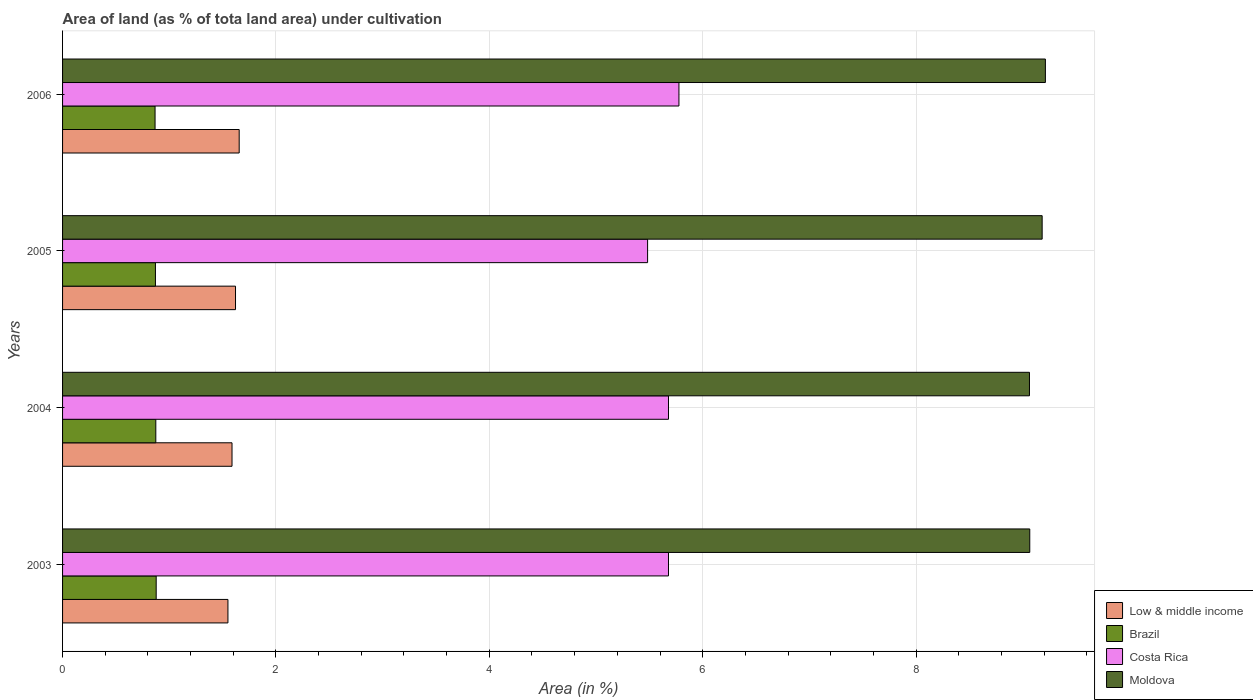How many groups of bars are there?
Offer a very short reply. 4. Are the number of bars on each tick of the Y-axis equal?
Provide a short and direct response. Yes. How many bars are there on the 2nd tick from the bottom?
Make the answer very short. 4. What is the percentage of land under cultivation in Costa Rica in 2005?
Keep it short and to the point. 5.48. Across all years, what is the maximum percentage of land under cultivation in Costa Rica?
Your answer should be very brief. 5.78. Across all years, what is the minimum percentage of land under cultivation in Brazil?
Provide a short and direct response. 0.87. In which year was the percentage of land under cultivation in Brazil minimum?
Your answer should be compact. 2006. What is the total percentage of land under cultivation in Moldova in the graph?
Ensure brevity in your answer.  36.52. What is the difference between the percentage of land under cultivation in Low & middle income in 2004 and that in 2006?
Your response must be concise. -0.07. What is the difference between the percentage of land under cultivation in Costa Rica in 2004 and the percentage of land under cultivation in Low & middle income in 2005?
Ensure brevity in your answer.  4.06. What is the average percentage of land under cultivation in Brazil per year?
Your answer should be very brief. 0.87. In the year 2004, what is the difference between the percentage of land under cultivation in Moldova and percentage of land under cultivation in Costa Rica?
Offer a very short reply. 3.38. What is the ratio of the percentage of land under cultivation in Costa Rica in 2004 to that in 2005?
Your response must be concise. 1.04. Is the difference between the percentage of land under cultivation in Moldova in 2003 and 2004 greater than the difference between the percentage of land under cultivation in Costa Rica in 2003 and 2004?
Offer a very short reply. Yes. What is the difference between the highest and the second highest percentage of land under cultivation in Low & middle income?
Your answer should be compact. 0.03. What is the difference between the highest and the lowest percentage of land under cultivation in Low & middle income?
Provide a short and direct response. 0.11. What does the 4th bar from the top in 2004 represents?
Make the answer very short. Low & middle income. How many bars are there?
Your answer should be very brief. 16. Are all the bars in the graph horizontal?
Your response must be concise. Yes. What is the difference between two consecutive major ticks on the X-axis?
Offer a terse response. 2. Where does the legend appear in the graph?
Your answer should be compact. Bottom right. How many legend labels are there?
Provide a succinct answer. 4. What is the title of the graph?
Offer a terse response. Area of land (as % of tota land area) under cultivation. What is the label or title of the X-axis?
Provide a short and direct response. Area (in %). What is the label or title of the Y-axis?
Provide a short and direct response. Years. What is the Area (in %) of Low & middle income in 2003?
Keep it short and to the point. 1.55. What is the Area (in %) in Brazil in 2003?
Keep it short and to the point. 0.88. What is the Area (in %) in Costa Rica in 2003?
Your response must be concise. 5.68. What is the Area (in %) of Moldova in 2003?
Ensure brevity in your answer.  9.07. What is the Area (in %) of Low & middle income in 2004?
Make the answer very short. 1.59. What is the Area (in %) in Brazil in 2004?
Your response must be concise. 0.87. What is the Area (in %) in Costa Rica in 2004?
Offer a terse response. 5.68. What is the Area (in %) in Moldova in 2004?
Your answer should be compact. 9.06. What is the Area (in %) of Low & middle income in 2005?
Your answer should be very brief. 1.62. What is the Area (in %) of Brazil in 2005?
Give a very brief answer. 0.87. What is the Area (in %) of Costa Rica in 2005?
Your answer should be very brief. 5.48. What is the Area (in %) in Moldova in 2005?
Make the answer very short. 9.18. What is the Area (in %) of Low & middle income in 2006?
Provide a succinct answer. 1.66. What is the Area (in %) in Brazil in 2006?
Give a very brief answer. 0.87. What is the Area (in %) of Costa Rica in 2006?
Ensure brevity in your answer.  5.78. What is the Area (in %) in Moldova in 2006?
Your answer should be compact. 9.21. Across all years, what is the maximum Area (in %) in Low & middle income?
Give a very brief answer. 1.66. Across all years, what is the maximum Area (in %) of Brazil?
Make the answer very short. 0.88. Across all years, what is the maximum Area (in %) in Costa Rica?
Offer a very short reply. 5.78. Across all years, what is the maximum Area (in %) of Moldova?
Keep it short and to the point. 9.21. Across all years, what is the minimum Area (in %) in Low & middle income?
Your answer should be compact. 1.55. Across all years, what is the minimum Area (in %) of Brazil?
Ensure brevity in your answer.  0.87. Across all years, what is the minimum Area (in %) of Costa Rica?
Your answer should be compact. 5.48. Across all years, what is the minimum Area (in %) in Moldova?
Give a very brief answer. 9.06. What is the total Area (in %) of Low & middle income in the graph?
Your answer should be compact. 6.42. What is the total Area (in %) of Brazil in the graph?
Keep it short and to the point. 3.49. What is the total Area (in %) of Costa Rica in the graph?
Your answer should be compact. 22.62. What is the total Area (in %) of Moldova in the graph?
Your answer should be compact. 36.52. What is the difference between the Area (in %) in Low & middle income in 2003 and that in 2004?
Your response must be concise. -0.04. What is the difference between the Area (in %) in Brazil in 2003 and that in 2004?
Provide a succinct answer. 0. What is the difference between the Area (in %) of Costa Rica in 2003 and that in 2004?
Your response must be concise. 0. What is the difference between the Area (in %) in Moldova in 2003 and that in 2004?
Ensure brevity in your answer.  0. What is the difference between the Area (in %) of Low & middle income in 2003 and that in 2005?
Make the answer very short. -0.07. What is the difference between the Area (in %) of Brazil in 2003 and that in 2005?
Keep it short and to the point. 0.01. What is the difference between the Area (in %) in Costa Rica in 2003 and that in 2005?
Provide a succinct answer. 0.2. What is the difference between the Area (in %) in Moldova in 2003 and that in 2005?
Ensure brevity in your answer.  -0.12. What is the difference between the Area (in %) in Low & middle income in 2003 and that in 2006?
Provide a short and direct response. -0.11. What is the difference between the Area (in %) of Brazil in 2003 and that in 2006?
Your answer should be very brief. 0.01. What is the difference between the Area (in %) of Costa Rica in 2003 and that in 2006?
Your answer should be compact. -0.1. What is the difference between the Area (in %) in Moldova in 2003 and that in 2006?
Make the answer very short. -0.15. What is the difference between the Area (in %) of Low & middle income in 2004 and that in 2005?
Give a very brief answer. -0.03. What is the difference between the Area (in %) of Brazil in 2004 and that in 2005?
Your answer should be very brief. 0. What is the difference between the Area (in %) of Costa Rica in 2004 and that in 2005?
Your response must be concise. 0.2. What is the difference between the Area (in %) of Moldova in 2004 and that in 2005?
Provide a short and direct response. -0.12. What is the difference between the Area (in %) of Low & middle income in 2004 and that in 2006?
Keep it short and to the point. -0.07. What is the difference between the Area (in %) of Brazil in 2004 and that in 2006?
Ensure brevity in your answer.  0.01. What is the difference between the Area (in %) of Costa Rica in 2004 and that in 2006?
Make the answer very short. -0.1. What is the difference between the Area (in %) of Moldova in 2004 and that in 2006?
Ensure brevity in your answer.  -0.15. What is the difference between the Area (in %) in Low & middle income in 2005 and that in 2006?
Provide a short and direct response. -0.03. What is the difference between the Area (in %) in Brazil in 2005 and that in 2006?
Your answer should be compact. 0. What is the difference between the Area (in %) of Costa Rica in 2005 and that in 2006?
Provide a short and direct response. -0.29. What is the difference between the Area (in %) of Moldova in 2005 and that in 2006?
Your response must be concise. -0.03. What is the difference between the Area (in %) of Low & middle income in 2003 and the Area (in %) of Brazil in 2004?
Provide a short and direct response. 0.68. What is the difference between the Area (in %) in Low & middle income in 2003 and the Area (in %) in Costa Rica in 2004?
Offer a very short reply. -4.13. What is the difference between the Area (in %) of Low & middle income in 2003 and the Area (in %) of Moldova in 2004?
Ensure brevity in your answer.  -7.51. What is the difference between the Area (in %) in Brazil in 2003 and the Area (in %) in Costa Rica in 2004?
Make the answer very short. -4.8. What is the difference between the Area (in %) of Brazil in 2003 and the Area (in %) of Moldova in 2004?
Offer a terse response. -8.19. What is the difference between the Area (in %) of Costa Rica in 2003 and the Area (in %) of Moldova in 2004?
Your response must be concise. -3.38. What is the difference between the Area (in %) in Low & middle income in 2003 and the Area (in %) in Brazil in 2005?
Give a very brief answer. 0.68. What is the difference between the Area (in %) in Low & middle income in 2003 and the Area (in %) in Costa Rica in 2005?
Offer a very short reply. -3.93. What is the difference between the Area (in %) in Low & middle income in 2003 and the Area (in %) in Moldova in 2005?
Your answer should be compact. -7.63. What is the difference between the Area (in %) of Brazil in 2003 and the Area (in %) of Costa Rica in 2005?
Offer a terse response. -4.61. What is the difference between the Area (in %) of Brazil in 2003 and the Area (in %) of Moldova in 2005?
Your answer should be very brief. -8.3. What is the difference between the Area (in %) of Costa Rica in 2003 and the Area (in %) of Moldova in 2005?
Your response must be concise. -3.5. What is the difference between the Area (in %) of Low & middle income in 2003 and the Area (in %) of Brazil in 2006?
Offer a terse response. 0.68. What is the difference between the Area (in %) of Low & middle income in 2003 and the Area (in %) of Costa Rica in 2006?
Make the answer very short. -4.23. What is the difference between the Area (in %) in Low & middle income in 2003 and the Area (in %) in Moldova in 2006?
Your response must be concise. -7.66. What is the difference between the Area (in %) of Brazil in 2003 and the Area (in %) of Costa Rica in 2006?
Make the answer very short. -4.9. What is the difference between the Area (in %) in Brazil in 2003 and the Area (in %) in Moldova in 2006?
Provide a short and direct response. -8.33. What is the difference between the Area (in %) of Costa Rica in 2003 and the Area (in %) of Moldova in 2006?
Provide a short and direct response. -3.53. What is the difference between the Area (in %) of Low & middle income in 2004 and the Area (in %) of Brazil in 2005?
Your answer should be very brief. 0.72. What is the difference between the Area (in %) in Low & middle income in 2004 and the Area (in %) in Costa Rica in 2005?
Your answer should be very brief. -3.9. What is the difference between the Area (in %) in Low & middle income in 2004 and the Area (in %) in Moldova in 2005?
Make the answer very short. -7.59. What is the difference between the Area (in %) in Brazil in 2004 and the Area (in %) in Costa Rica in 2005?
Provide a succinct answer. -4.61. What is the difference between the Area (in %) of Brazil in 2004 and the Area (in %) of Moldova in 2005?
Give a very brief answer. -8.31. What is the difference between the Area (in %) in Costa Rica in 2004 and the Area (in %) in Moldova in 2005?
Your answer should be compact. -3.5. What is the difference between the Area (in %) of Low & middle income in 2004 and the Area (in %) of Brazil in 2006?
Make the answer very short. 0.72. What is the difference between the Area (in %) in Low & middle income in 2004 and the Area (in %) in Costa Rica in 2006?
Make the answer very short. -4.19. What is the difference between the Area (in %) in Low & middle income in 2004 and the Area (in %) in Moldova in 2006?
Provide a succinct answer. -7.62. What is the difference between the Area (in %) of Brazil in 2004 and the Area (in %) of Costa Rica in 2006?
Your answer should be compact. -4.9. What is the difference between the Area (in %) in Brazil in 2004 and the Area (in %) in Moldova in 2006?
Provide a succinct answer. -8.34. What is the difference between the Area (in %) of Costa Rica in 2004 and the Area (in %) of Moldova in 2006?
Your answer should be very brief. -3.53. What is the difference between the Area (in %) in Low & middle income in 2005 and the Area (in %) in Brazil in 2006?
Give a very brief answer. 0.75. What is the difference between the Area (in %) in Low & middle income in 2005 and the Area (in %) in Costa Rica in 2006?
Offer a terse response. -4.16. What is the difference between the Area (in %) of Low & middle income in 2005 and the Area (in %) of Moldova in 2006?
Provide a short and direct response. -7.59. What is the difference between the Area (in %) of Brazil in 2005 and the Area (in %) of Costa Rica in 2006?
Give a very brief answer. -4.91. What is the difference between the Area (in %) of Brazil in 2005 and the Area (in %) of Moldova in 2006?
Give a very brief answer. -8.34. What is the difference between the Area (in %) in Costa Rica in 2005 and the Area (in %) in Moldova in 2006?
Make the answer very short. -3.73. What is the average Area (in %) in Low & middle income per year?
Ensure brevity in your answer.  1.6. What is the average Area (in %) in Brazil per year?
Your response must be concise. 0.87. What is the average Area (in %) of Costa Rica per year?
Your answer should be very brief. 5.66. What is the average Area (in %) in Moldova per year?
Offer a very short reply. 9.13. In the year 2003, what is the difference between the Area (in %) of Low & middle income and Area (in %) of Brazil?
Provide a short and direct response. 0.67. In the year 2003, what is the difference between the Area (in %) in Low & middle income and Area (in %) in Costa Rica?
Ensure brevity in your answer.  -4.13. In the year 2003, what is the difference between the Area (in %) in Low & middle income and Area (in %) in Moldova?
Your response must be concise. -7.52. In the year 2003, what is the difference between the Area (in %) of Brazil and Area (in %) of Costa Rica?
Provide a succinct answer. -4.8. In the year 2003, what is the difference between the Area (in %) of Brazil and Area (in %) of Moldova?
Your answer should be compact. -8.19. In the year 2003, what is the difference between the Area (in %) of Costa Rica and Area (in %) of Moldova?
Offer a very short reply. -3.39. In the year 2004, what is the difference between the Area (in %) in Low & middle income and Area (in %) in Brazil?
Provide a succinct answer. 0.71. In the year 2004, what is the difference between the Area (in %) in Low & middle income and Area (in %) in Costa Rica?
Make the answer very short. -4.09. In the year 2004, what is the difference between the Area (in %) of Low & middle income and Area (in %) of Moldova?
Your answer should be very brief. -7.47. In the year 2004, what is the difference between the Area (in %) of Brazil and Area (in %) of Costa Rica?
Ensure brevity in your answer.  -4.81. In the year 2004, what is the difference between the Area (in %) of Brazil and Area (in %) of Moldova?
Your answer should be compact. -8.19. In the year 2004, what is the difference between the Area (in %) in Costa Rica and Area (in %) in Moldova?
Provide a succinct answer. -3.38. In the year 2005, what is the difference between the Area (in %) in Low & middle income and Area (in %) in Brazil?
Your response must be concise. 0.75. In the year 2005, what is the difference between the Area (in %) of Low & middle income and Area (in %) of Costa Rica?
Provide a short and direct response. -3.86. In the year 2005, what is the difference between the Area (in %) in Low & middle income and Area (in %) in Moldova?
Provide a succinct answer. -7.56. In the year 2005, what is the difference between the Area (in %) in Brazil and Area (in %) in Costa Rica?
Offer a very short reply. -4.61. In the year 2005, what is the difference between the Area (in %) of Brazil and Area (in %) of Moldova?
Make the answer very short. -8.31. In the year 2005, what is the difference between the Area (in %) in Costa Rica and Area (in %) in Moldova?
Offer a very short reply. -3.7. In the year 2006, what is the difference between the Area (in %) of Low & middle income and Area (in %) of Brazil?
Give a very brief answer. 0.79. In the year 2006, what is the difference between the Area (in %) of Low & middle income and Area (in %) of Costa Rica?
Keep it short and to the point. -4.12. In the year 2006, what is the difference between the Area (in %) in Low & middle income and Area (in %) in Moldova?
Keep it short and to the point. -7.56. In the year 2006, what is the difference between the Area (in %) of Brazil and Area (in %) of Costa Rica?
Make the answer very short. -4.91. In the year 2006, what is the difference between the Area (in %) in Brazil and Area (in %) in Moldova?
Offer a terse response. -8.35. In the year 2006, what is the difference between the Area (in %) of Costa Rica and Area (in %) of Moldova?
Offer a terse response. -3.44. What is the ratio of the Area (in %) of Low & middle income in 2003 to that in 2004?
Give a very brief answer. 0.98. What is the ratio of the Area (in %) of Costa Rica in 2003 to that in 2004?
Offer a very short reply. 1. What is the ratio of the Area (in %) of Moldova in 2003 to that in 2004?
Give a very brief answer. 1. What is the ratio of the Area (in %) of Low & middle income in 2003 to that in 2005?
Your answer should be very brief. 0.96. What is the ratio of the Area (in %) of Brazil in 2003 to that in 2005?
Offer a very short reply. 1.01. What is the ratio of the Area (in %) in Costa Rica in 2003 to that in 2005?
Provide a succinct answer. 1.04. What is the ratio of the Area (in %) of Moldova in 2003 to that in 2005?
Provide a short and direct response. 0.99. What is the ratio of the Area (in %) of Low & middle income in 2003 to that in 2006?
Give a very brief answer. 0.94. What is the ratio of the Area (in %) of Brazil in 2003 to that in 2006?
Provide a succinct answer. 1.01. What is the ratio of the Area (in %) of Costa Rica in 2003 to that in 2006?
Make the answer very short. 0.98. What is the ratio of the Area (in %) of Moldova in 2003 to that in 2006?
Provide a short and direct response. 0.98. What is the ratio of the Area (in %) in Low & middle income in 2004 to that in 2005?
Your answer should be very brief. 0.98. What is the ratio of the Area (in %) of Brazil in 2004 to that in 2005?
Provide a short and direct response. 1. What is the ratio of the Area (in %) in Costa Rica in 2004 to that in 2005?
Make the answer very short. 1.04. What is the ratio of the Area (in %) of Moldova in 2004 to that in 2005?
Ensure brevity in your answer.  0.99. What is the ratio of the Area (in %) of Low & middle income in 2004 to that in 2006?
Your answer should be compact. 0.96. What is the ratio of the Area (in %) of Brazil in 2004 to that in 2006?
Your response must be concise. 1.01. What is the ratio of the Area (in %) of Costa Rica in 2004 to that in 2006?
Keep it short and to the point. 0.98. What is the ratio of the Area (in %) in Moldova in 2004 to that in 2006?
Ensure brevity in your answer.  0.98. What is the ratio of the Area (in %) in Low & middle income in 2005 to that in 2006?
Give a very brief answer. 0.98. What is the ratio of the Area (in %) of Costa Rica in 2005 to that in 2006?
Keep it short and to the point. 0.95. What is the difference between the highest and the second highest Area (in %) in Low & middle income?
Provide a succinct answer. 0.03. What is the difference between the highest and the second highest Area (in %) of Brazil?
Your answer should be compact. 0. What is the difference between the highest and the second highest Area (in %) in Costa Rica?
Provide a succinct answer. 0.1. What is the difference between the highest and the second highest Area (in %) in Moldova?
Your response must be concise. 0.03. What is the difference between the highest and the lowest Area (in %) in Low & middle income?
Make the answer very short. 0.11. What is the difference between the highest and the lowest Area (in %) of Brazil?
Make the answer very short. 0.01. What is the difference between the highest and the lowest Area (in %) in Costa Rica?
Offer a very short reply. 0.29. What is the difference between the highest and the lowest Area (in %) in Moldova?
Give a very brief answer. 0.15. 